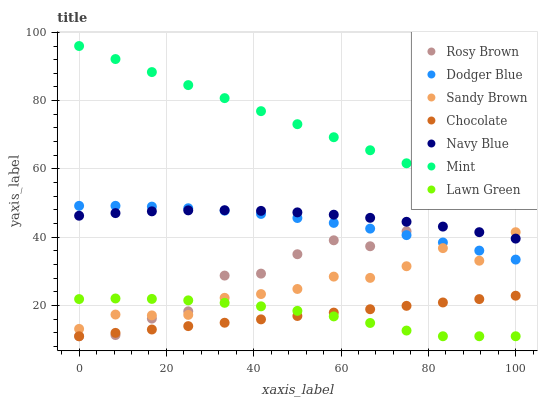Does Chocolate have the minimum area under the curve?
Answer yes or no. Yes. Does Mint have the maximum area under the curve?
Answer yes or no. Yes. Does Navy Blue have the minimum area under the curve?
Answer yes or no. No. Does Navy Blue have the maximum area under the curve?
Answer yes or no. No. Is Chocolate the smoothest?
Answer yes or no. Yes. Is Rosy Brown the roughest?
Answer yes or no. Yes. Is Navy Blue the smoothest?
Answer yes or no. No. Is Navy Blue the roughest?
Answer yes or no. No. Does Lawn Green have the lowest value?
Answer yes or no. Yes. Does Navy Blue have the lowest value?
Answer yes or no. No. Does Mint have the highest value?
Answer yes or no. Yes. Does Navy Blue have the highest value?
Answer yes or no. No. Is Dodger Blue less than Mint?
Answer yes or no. Yes. Is Mint greater than Chocolate?
Answer yes or no. Yes. Does Chocolate intersect Rosy Brown?
Answer yes or no. Yes. Is Chocolate less than Rosy Brown?
Answer yes or no. No. Is Chocolate greater than Rosy Brown?
Answer yes or no. No. Does Dodger Blue intersect Mint?
Answer yes or no. No. 